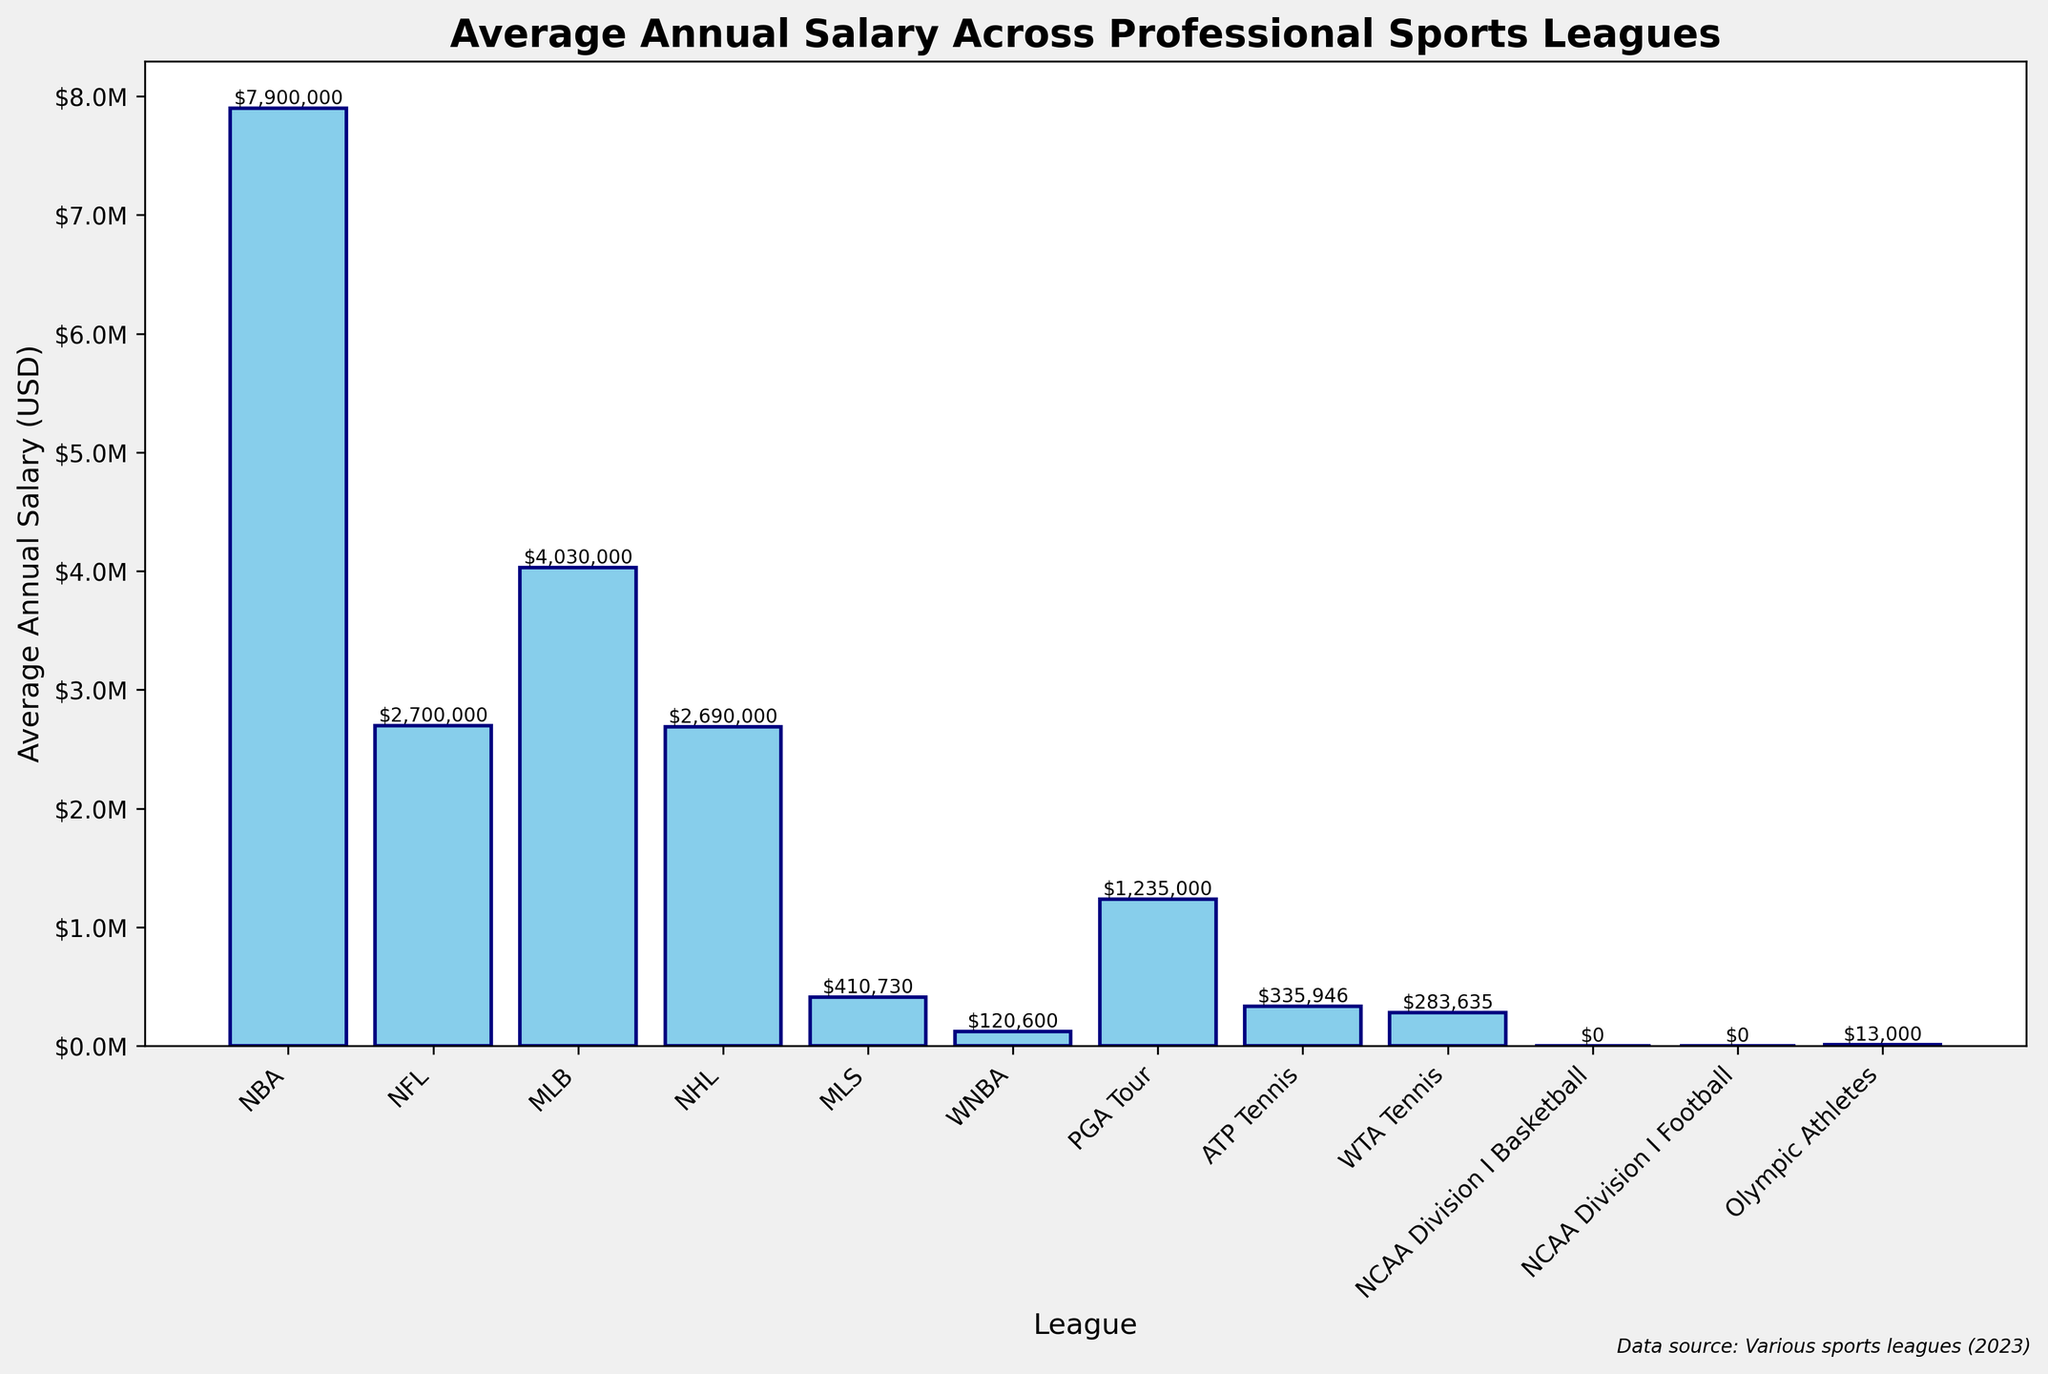Which league has the highest average annual salary? To find the highest average annual salary, we compare the heights of the bars. The bar for the NBA is the tallest, indicating it has the highest salary.
Answer: NBA How much more does an average NBA player make compared to an average NFL player annually? To calculate the difference, subtract the NFL's average salary from the NBA's average salary. NBA: $7,900,000 and NFL: $2,700,000, so the difference is $7,900,000 - $2,700,000.
Answer: $5,200,000 Which leagues have players earning less than $1 million annually on average? Look for the bars below the $1M mark. MLS, WNBA, ATP Tennis, WTA Tennis, NCAA Division I Basketball, NCAA Division I Football, and Olympic Athletes all fall below this threshold.
Answer: MLS, WNBA, ATP Tennis, WTA Tennis, NCAA Division I Basketball, NCAA Division I Football, Olympic Athletes What is the sum of the average annual salaries of athletes in PGA Tour and NHL? Add the average salaries of PGA Tour ($1,235,000) and NHL ($2,690,000).
Answer: $3,925,000 Which league's average salary is closest to $4M? Compare the bars visually around the $4M mark. MLB has an average salary of $4,030,000, which is closest to $4M.
Answer: MLB How does the average salary of Olympic athletes compare to that of WNBA players? Olympic athletes have an average salary of $13,000, which is significantly lower than that of WNBA players, who earn $120,600 on average.
Answer: It's lower What's the average salary difference between MLS and ATP Tennis? Find the difference between the salaries of MLS ($410,730) and ATP Tennis ($335,946). Subtract ATP Tennis from MLS.
Answer: $74,784 Is the average salary of a PGA Tour player more than twice that of a WNBA player? Compare twice the WNBA's average salary ($120,600 * 2 = $241,200) with that of the PGA Tour ($1,235,000). $1,235,000 is indeed more than $241,200.
Answer: Yes How many leagues have an average salary above $1 million annually? Count the bars that are above the $1M mark. NBA, NFL, MLB, NHL, PGA Tour all fall into this category.
Answer: 5 If we combine the average salaries of NCAA Division I Basketball and NCAA Division I Football, what would the total be? Since both have an average salary of $0, their combined total is $0.
Answer: $0 